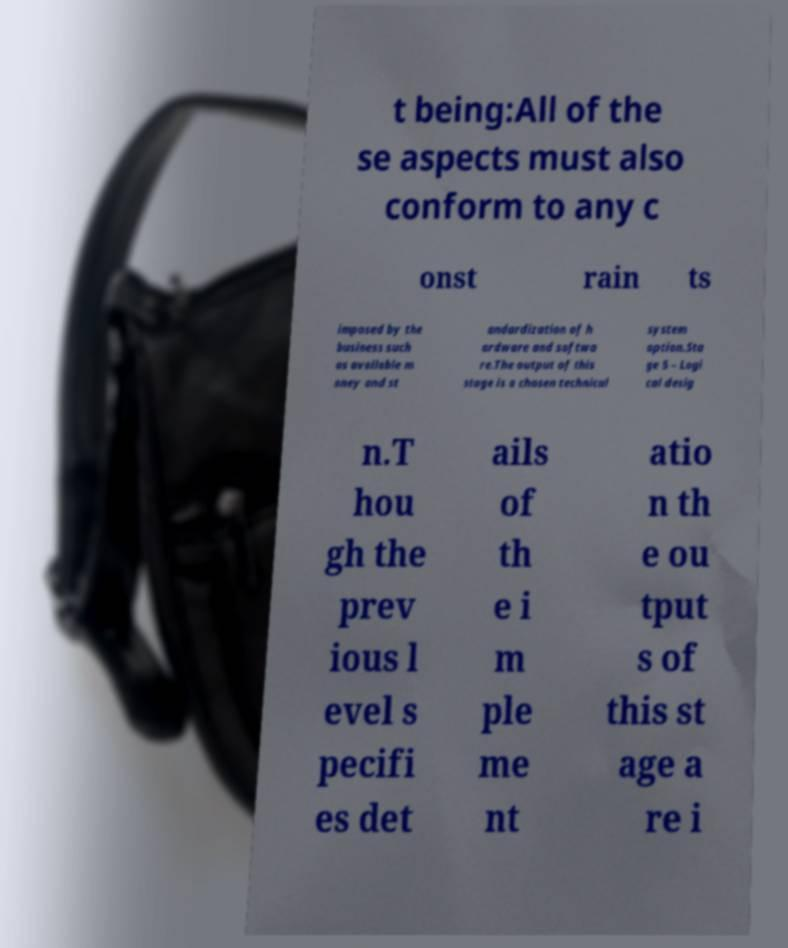Please identify and transcribe the text found in this image. t being:All of the se aspects must also conform to any c onst rain ts imposed by the business such as available m oney and st andardization of h ardware and softwa re.The output of this stage is a chosen technical system option.Sta ge 5 – Logi cal desig n.T hou gh the prev ious l evel s pecifi es det ails of th e i m ple me nt atio n th e ou tput s of this st age a re i 